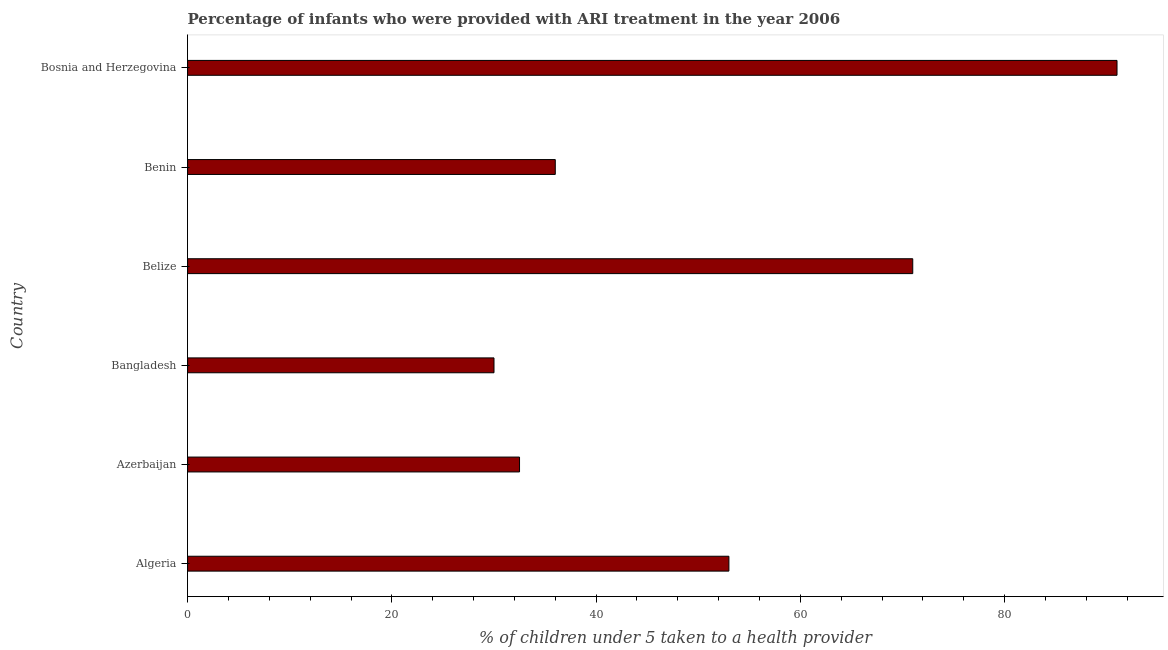What is the title of the graph?
Your answer should be very brief. Percentage of infants who were provided with ARI treatment in the year 2006. What is the label or title of the X-axis?
Give a very brief answer. % of children under 5 taken to a health provider. What is the label or title of the Y-axis?
Provide a succinct answer. Country. What is the percentage of children who were provided with ari treatment in Algeria?
Your answer should be very brief. 53. Across all countries, what is the maximum percentage of children who were provided with ari treatment?
Offer a terse response. 91. Across all countries, what is the minimum percentage of children who were provided with ari treatment?
Your response must be concise. 30. In which country was the percentage of children who were provided with ari treatment maximum?
Ensure brevity in your answer.  Bosnia and Herzegovina. In which country was the percentage of children who were provided with ari treatment minimum?
Your answer should be very brief. Bangladesh. What is the sum of the percentage of children who were provided with ari treatment?
Keep it short and to the point. 313.5. What is the difference between the percentage of children who were provided with ari treatment in Azerbaijan and Belize?
Provide a short and direct response. -38.5. What is the average percentage of children who were provided with ari treatment per country?
Offer a very short reply. 52.25. What is the median percentage of children who were provided with ari treatment?
Offer a very short reply. 44.5. In how many countries, is the percentage of children who were provided with ari treatment greater than 36 %?
Keep it short and to the point. 3. What is the ratio of the percentage of children who were provided with ari treatment in Algeria to that in Belize?
Your answer should be compact. 0.75. Is the difference between the percentage of children who were provided with ari treatment in Benin and Bosnia and Herzegovina greater than the difference between any two countries?
Make the answer very short. No. Is the sum of the percentage of children who were provided with ari treatment in Bangladesh and Benin greater than the maximum percentage of children who were provided with ari treatment across all countries?
Make the answer very short. No. In how many countries, is the percentage of children who were provided with ari treatment greater than the average percentage of children who were provided with ari treatment taken over all countries?
Offer a very short reply. 3. Are all the bars in the graph horizontal?
Ensure brevity in your answer.  Yes. What is the % of children under 5 taken to a health provider in Azerbaijan?
Your answer should be very brief. 32.5. What is the % of children under 5 taken to a health provider in Belize?
Your answer should be compact. 71. What is the % of children under 5 taken to a health provider in Bosnia and Herzegovina?
Keep it short and to the point. 91. What is the difference between the % of children under 5 taken to a health provider in Algeria and Azerbaijan?
Provide a succinct answer. 20.5. What is the difference between the % of children under 5 taken to a health provider in Algeria and Bangladesh?
Your response must be concise. 23. What is the difference between the % of children under 5 taken to a health provider in Algeria and Belize?
Keep it short and to the point. -18. What is the difference between the % of children under 5 taken to a health provider in Algeria and Benin?
Your answer should be very brief. 17. What is the difference between the % of children under 5 taken to a health provider in Algeria and Bosnia and Herzegovina?
Make the answer very short. -38. What is the difference between the % of children under 5 taken to a health provider in Azerbaijan and Bangladesh?
Offer a very short reply. 2.5. What is the difference between the % of children under 5 taken to a health provider in Azerbaijan and Belize?
Provide a short and direct response. -38.5. What is the difference between the % of children under 5 taken to a health provider in Azerbaijan and Bosnia and Herzegovina?
Your response must be concise. -58.5. What is the difference between the % of children under 5 taken to a health provider in Bangladesh and Belize?
Make the answer very short. -41. What is the difference between the % of children under 5 taken to a health provider in Bangladesh and Bosnia and Herzegovina?
Your response must be concise. -61. What is the difference between the % of children under 5 taken to a health provider in Benin and Bosnia and Herzegovina?
Offer a terse response. -55. What is the ratio of the % of children under 5 taken to a health provider in Algeria to that in Azerbaijan?
Make the answer very short. 1.63. What is the ratio of the % of children under 5 taken to a health provider in Algeria to that in Bangladesh?
Make the answer very short. 1.77. What is the ratio of the % of children under 5 taken to a health provider in Algeria to that in Belize?
Give a very brief answer. 0.75. What is the ratio of the % of children under 5 taken to a health provider in Algeria to that in Benin?
Give a very brief answer. 1.47. What is the ratio of the % of children under 5 taken to a health provider in Algeria to that in Bosnia and Herzegovina?
Keep it short and to the point. 0.58. What is the ratio of the % of children under 5 taken to a health provider in Azerbaijan to that in Bangladesh?
Ensure brevity in your answer.  1.08. What is the ratio of the % of children under 5 taken to a health provider in Azerbaijan to that in Belize?
Offer a terse response. 0.46. What is the ratio of the % of children under 5 taken to a health provider in Azerbaijan to that in Benin?
Your response must be concise. 0.9. What is the ratio of the % of children under 5 taken to a health provider in Azerbaijan to that in Bosnia and Herzegovina?
Offer a terse response. 0.36. What is the ratio of the % of children under 5 taken to a health provider in Bangladesh to that in Belize?
Provide a short and direct response. 0.42. What is the ratio of the % of children under 5 taken to a health provider in Bangladesh to that in Benin?
Provide a short and direct response. 0.83. What is the ratio of the % of children under 5 taken to a health provider in Bangladesh to that in Bosnia and Herzegovina?
Keep it short and to the point. 0.33. What is the ratio of the % of children under 5 taken to a health provider in Belize to that in Benin?
Your answer should be compact. 1.97. What is the ratio of the % of children under 5 taken to a health provider in Belize to that in Bosnia and Herzegovina?
Offer a terse response. 0.78. What is the ratio of the % of children under 5 taken to a health provider in Benin to that in Bosnia and Herzegovina?
Keep it short and to the point. 0.4. 